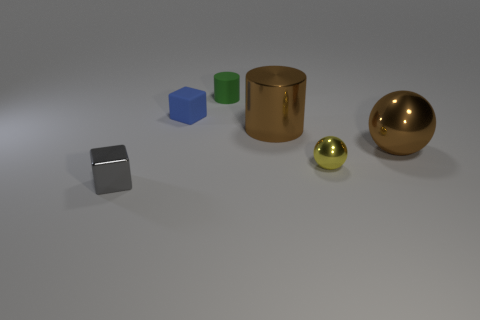What other objects are visible in the scene besides the small blocks? In addition to the small blocks, there's a medium-sized reflective gold cylinder and a large, shiny gold sphere present in the scene. 